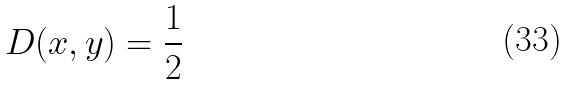<formula> <loc_0><loc_0><loc_500><loc_500>D ( x , y ) = \frac { 1 } { 2 }</formula> 